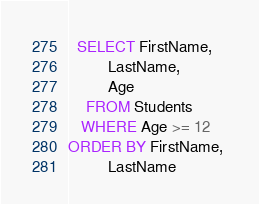<code> <loc_0><loc_0><loc_500><loc_500><_SQL_>  SELECT FirstName, 
         LastName, 
         Age
    FROM Students
   WHERE Age >= 12
ORDER BY FirstName, 
         LastName</code> 